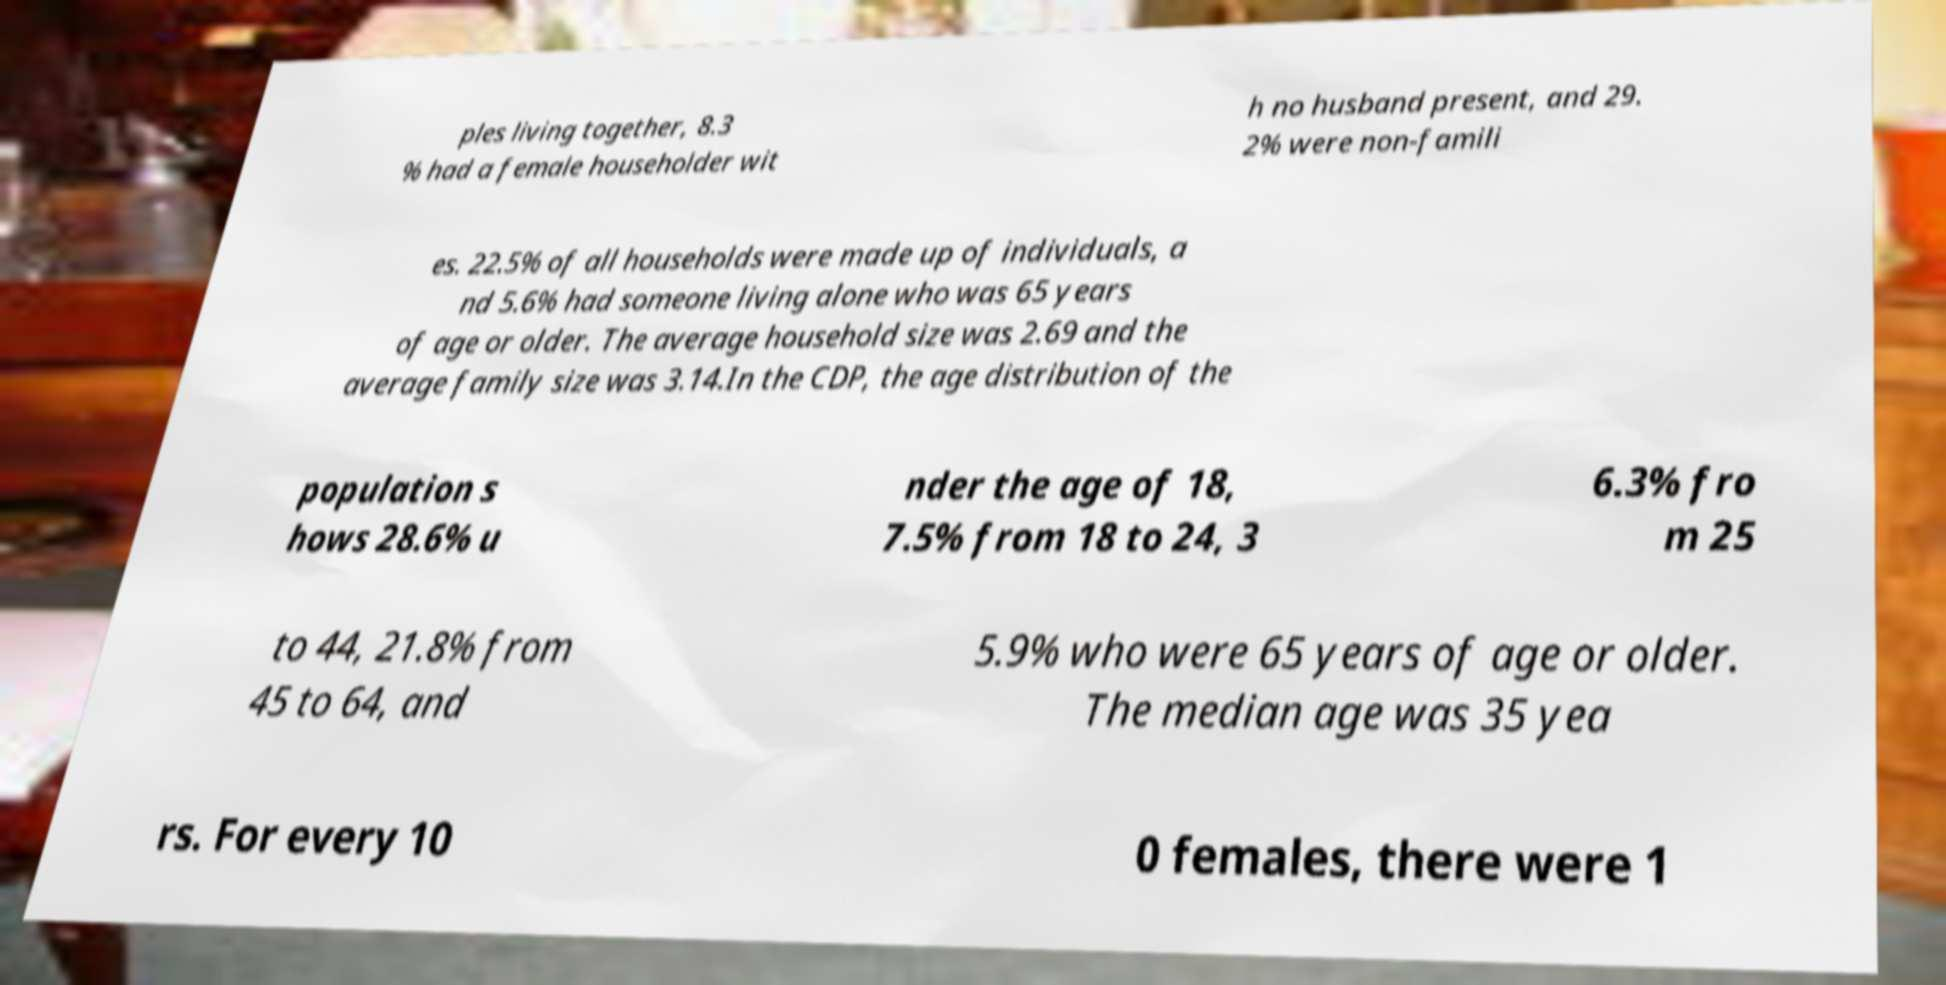There's text embedded in this image that I need extracted. Can you transcribe it verbatim? ples living together, 8.3 % had a female householder wit h no husband present, and 29. 2% were non-famili es. 22.5% of all households were made up of individuals, a nd 5.6% had someone living alone who was 65 years of age or older. The average household size was 2.69 and the average family size was 3.14.In the CDP, the age distribution of the population s hows 28.6% u nder the age of 18, 7.5% from 18 to 24, 3 6.3% fro m 25 to 44, 21.8% from 45 to 64, and 5.9% who were 65 years of age or older. The median age was 35 yea rs. For every 10 0 females, there were 1 